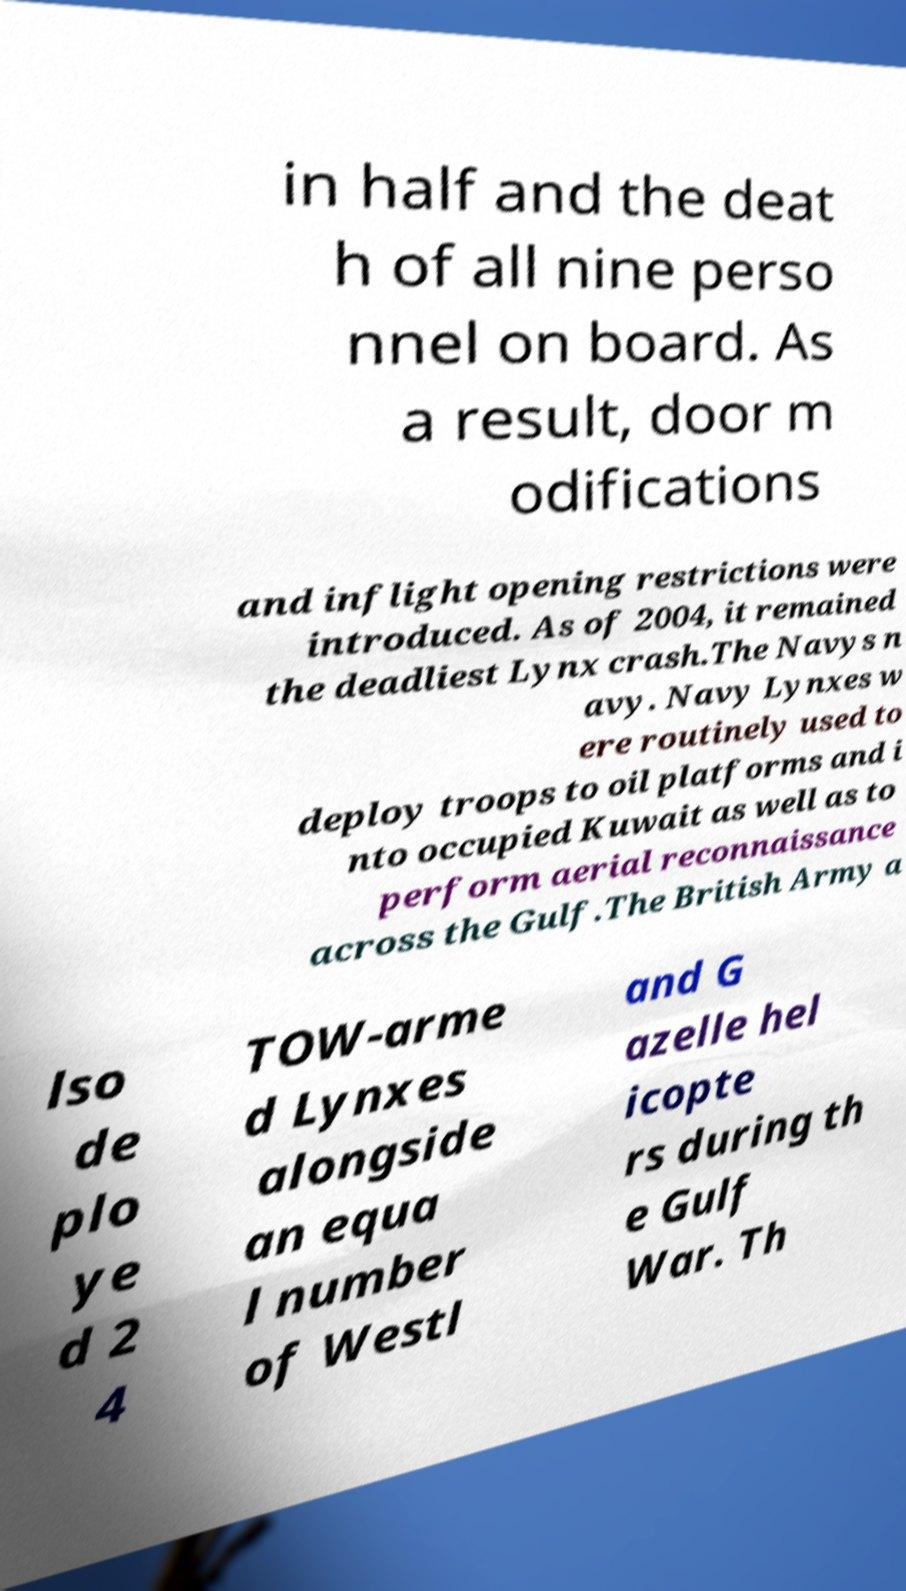There's text embedded in this image that I need extracted. Can you transcribe it verbatim? in half and the deat h of all nine perso nnel on board. As a result, door m odifications and inflight opening restrictions were introduced. As of 2004, it remained the deadliest Lynx crash.The Navys n avy. Navy Lynxes w ere routinely used to deploy troops to oil platforms and i nto occupied Kuwait as well as to perform aerial reconnaissance across the Gulf.The British Army a lso de plo ye d 2 4 TOW-arme d Lynxes alongside an equa l number of Westl and G azelle hel icopte rs during th e Gulf War. Th 